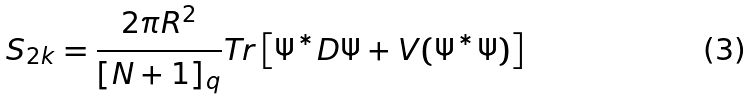<formula> <loc_0><loc_0><loc_500><loc_500>S _ { 2 k } = \frac { 2 \pi R ^ { 2 } } { [ N + 1 ] _ { q } } T r \left [ \Psi ^ { * } D \Psi + V ( \Psi ^ { * } \Psi ) \right ]</formula> 